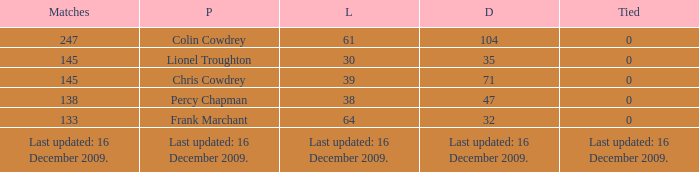I want to know the drawn that has a tie of 0 and the player is chris cowdrey 71.0. 